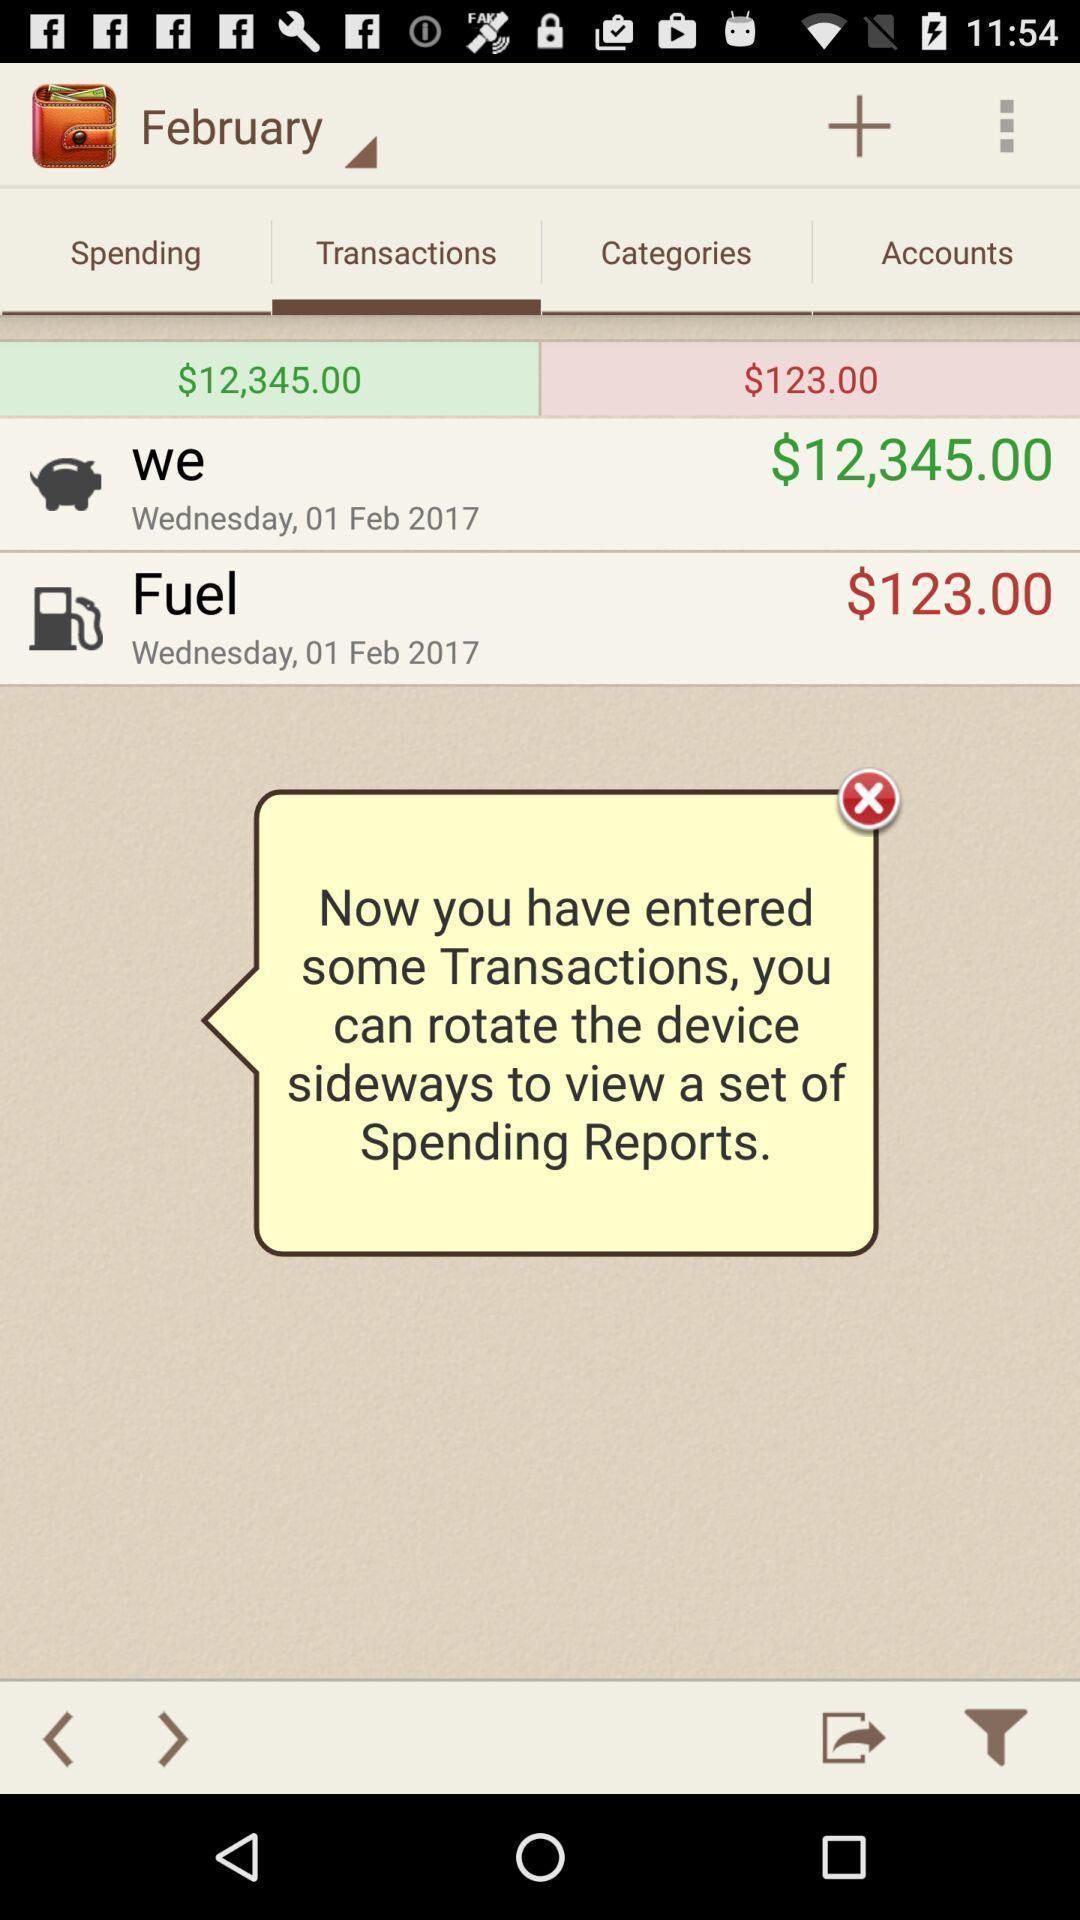Provide a description of this screenshot. Screen shows multiple options in a financial application. 